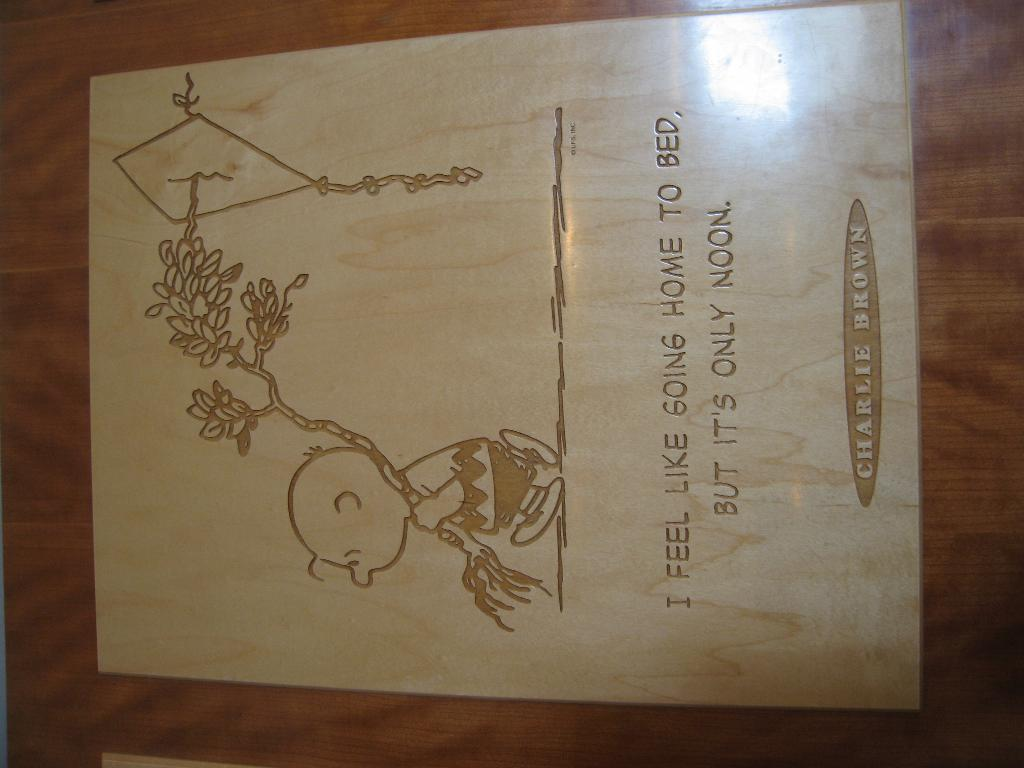What is the main subject of the image? The main subject of the image is a sketch. Can you describe any additional elements in the image? Yes, there is text on a card in the image. How many women are present in the image? There is no mention of women in the image, as it only contains a sketch and text on a card. 